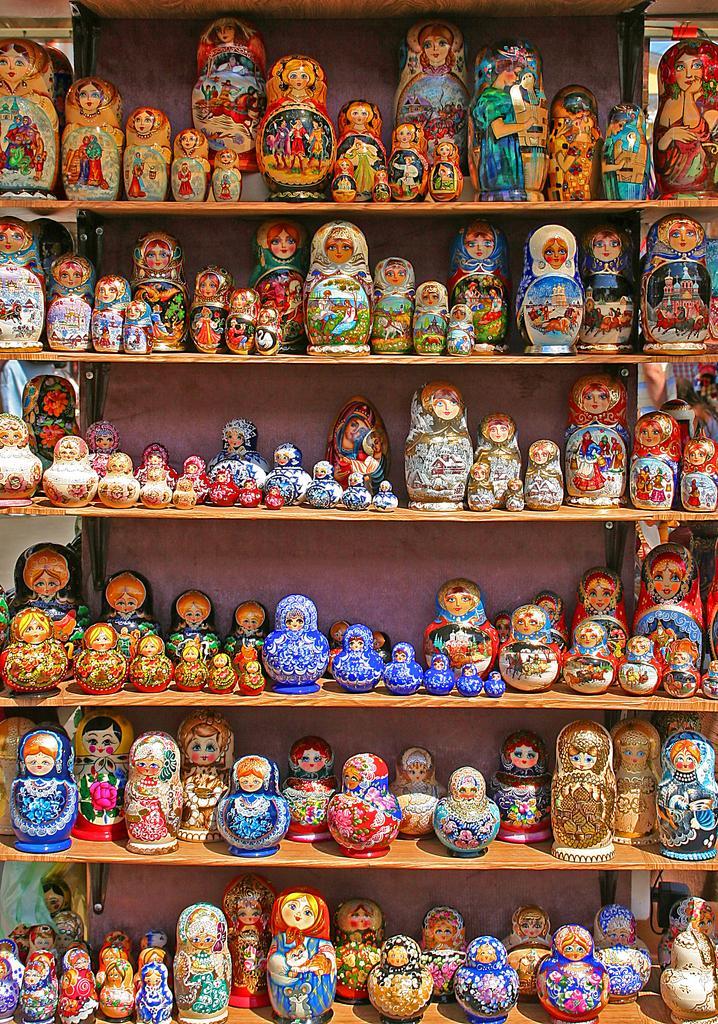Please provide a concise description of this image. In this picture I can see toys arranged in an order on the racks. 